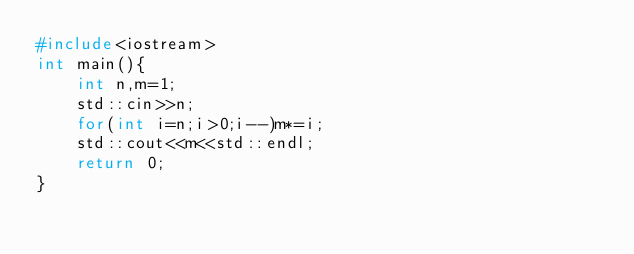<code> <loc_0><loc_0><loc_500><loc_500><_C++_>#include<iostream>
int main(){
	int n,m=1;
	std::cin>>n;
	for(int i=n;i>0;i--)m*=i;
	std::cout<<m<<std::endl;
	return 0;
}</code> 